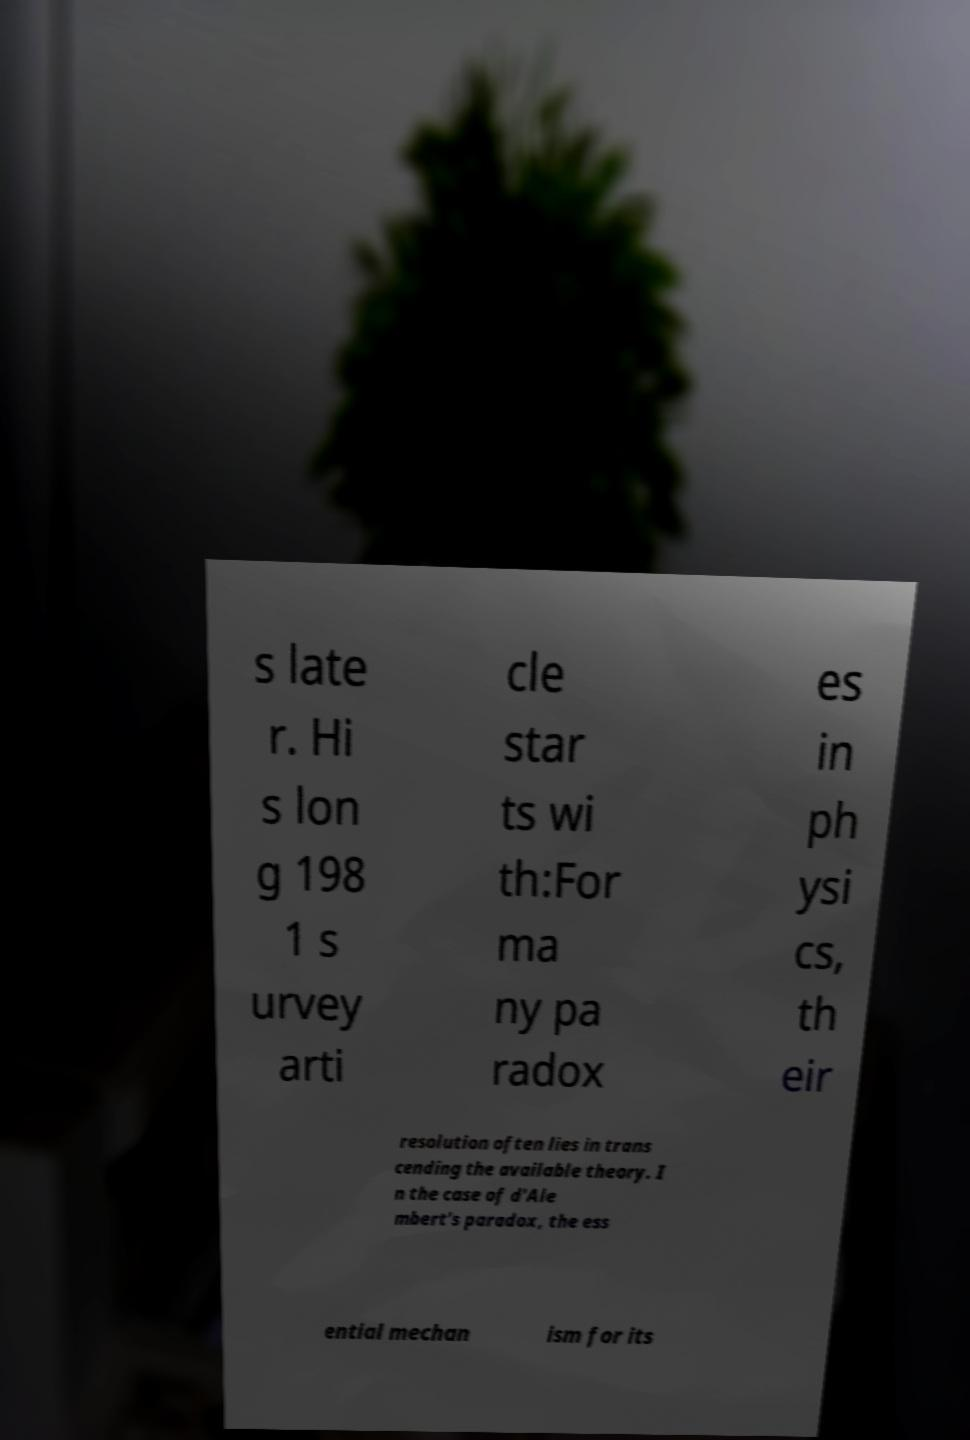Can you accurately transcribe the text from the provided image for me? s late r. Hi s lon g 198 1 s urvey arti cle star ts wi th:For ma ny pa radox es in ph ysi cs, th eir resolution often lies in trans cending the available theory. I n the case of d'Ale mbert's paradox, the ess ential mechan ism for its 